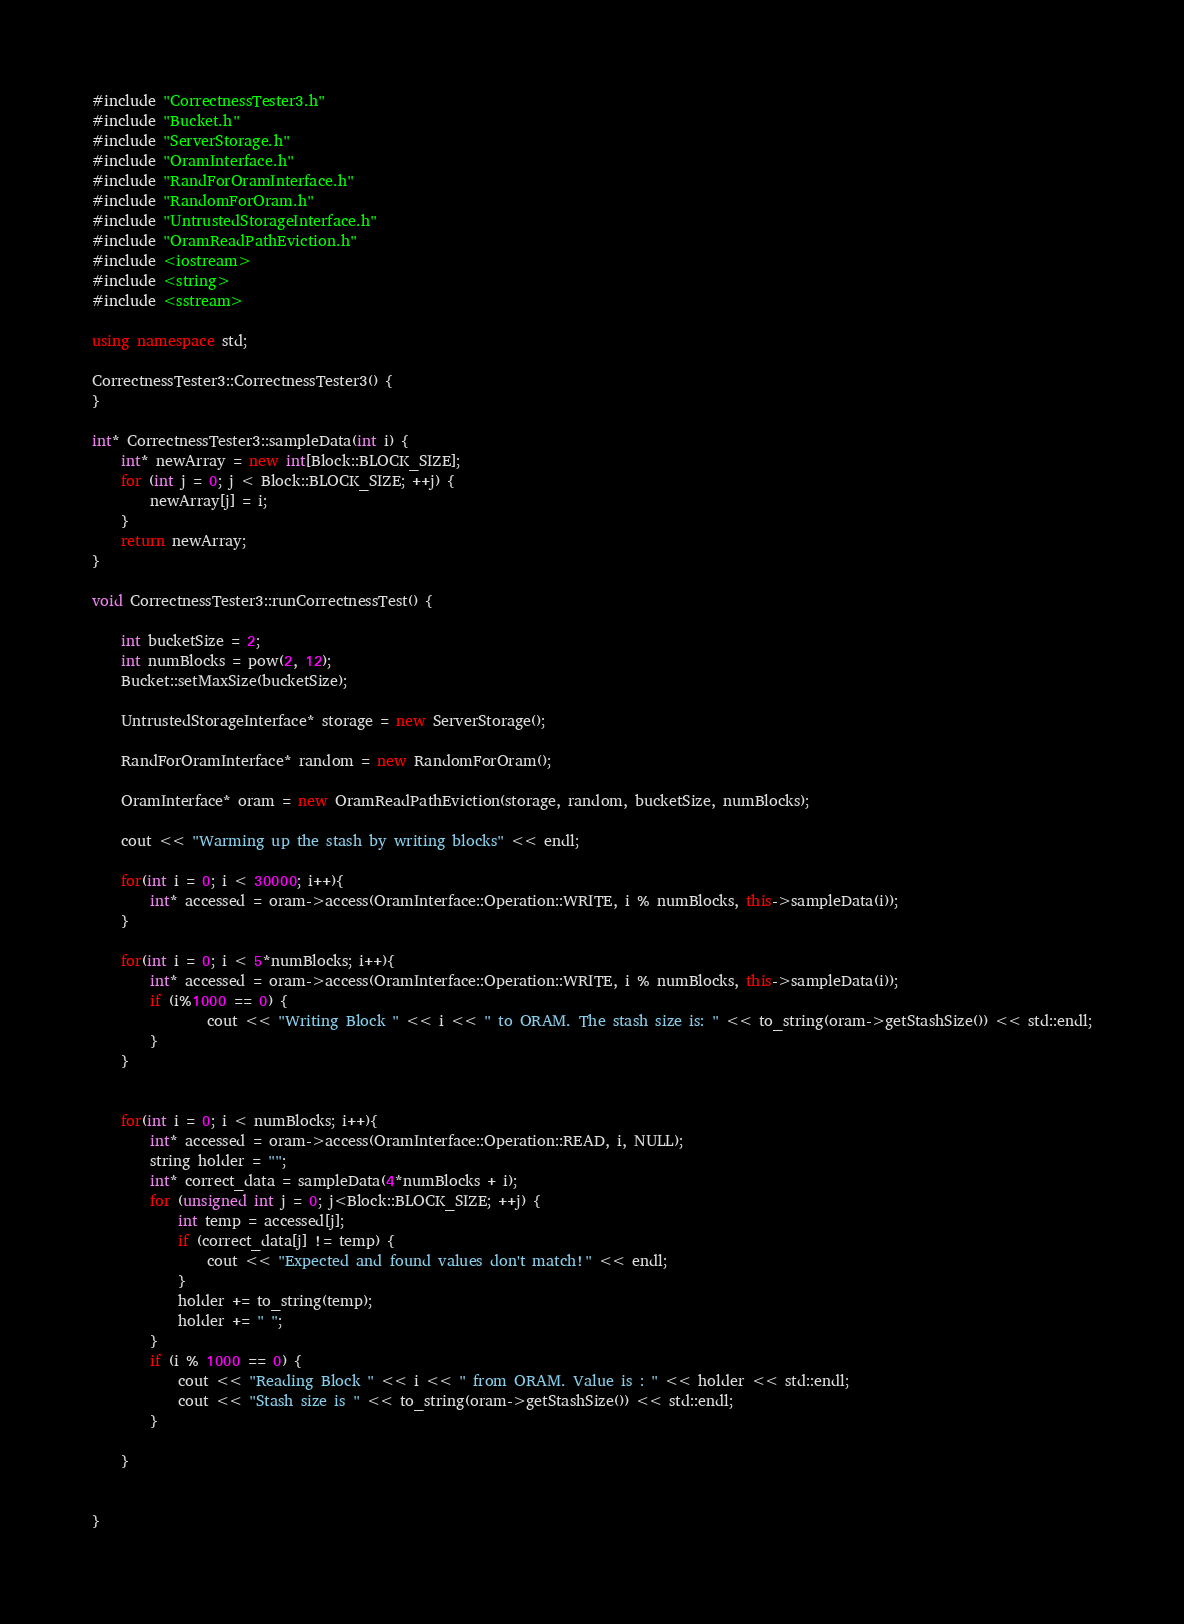<code> <loc_0><loc_0><loc_500><loc_500><_C++_>
#include "CorrectnessTester3.h"
#include "Bucket.h"
#include "ServerStorage.h"
#include "OramInterface.h"
#include "RandForOramInterface.h"
#include "RandomForOram.h"
#include "UntrustedStorageInterface.h"
#include "OramReadPathEviction.h"
#include <iostream>
#include <string>
#include <sstream>

using namespace std;

CorrectnessTester3::CorrectnessTester3() {
}

int* CorrectnessTester3::sampleData(int i) {
    int* newArray = new int[Block::BLOCK_SIZE];
    for (int j = 0; j < Block::BLOCK_SIZE; ++j) {
        newArray[j] = i;
    }
    return newArray;
}

void CorrectnessTester3::runCorrectnessTest() {

    int bucketSize = 2;
    int numBlocks = pow(2, 12);
    Bucket::setMaxSize(bucketSize);

    UntrustedStorageInterface* storage = new ServerStorage();

    RandForOramInterface* random = new RandomForOram();

    OramInterface* oram = new OramReadPathEviction(storage, random, bucketSize, numBlocks);

    cout << "Warming up the stash by writing blocks" << endl;

    for(int i = 0; i < 30000; i++){
        int* accessed = oram->access(OramInterface::Operation::WRITE, i % numBlocks, this->sampleData(i));
    }

    for(int i = 0; i < 5*numBlocks; i++){
        int* accessed = oram->access(OramInterface::Operation::WRITE, i % numBlocks, this->sampleData(i));
        if (i%1000 == 0) {
                cout << "Writing Block " << i << " to ORAM. The stash size is: " << to_string(oram->getStashSize()) << std::endl;
        }
    }


    for(int i = 0; i < numBlocks; i++){
        int* accessed = oram->access(OramInterface::Operation::READ, i, NULL);
        string holder = "";
        int* correct_data = sampleData(4*numBlocks + i);
        for (unsigned int j = 0; j<Block::BLOCK_SIZE; ++j) {
            int temp = accessed[j];
            if (correct_data[j] != temp) {
                cout << "Expected and found values don't match!" << endl;
            }
            holder += to_string(temp);
            holder += " ";
        }
        if (i % 1000 == 0) {
            cout << "Reading Block " << i << " from ORAM. Value is : " << holder << std::endl;
            cout << "Stash size is " << to_string(oram->getStashSize()) << std::endl;
        }

    }


}</code> 